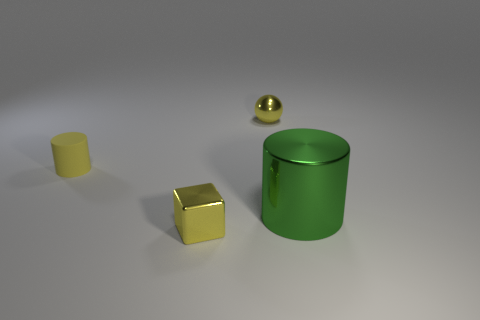What number of small yellow balls are there?
Your answer should be very brief. 1. What number of objects are green things or yellow matte blocks?
Ensure brevity in your answer.  1. There is a ball that is the same color as the rubber thing; what is its size?
Offer a very short reply. Small. There is a small metallic cube; are there any yellow matte things in front of it?
Your answer should be compact. No. Is the number of yellow objects that are behind the tiny yellow shiny cube greater than the number of big cylinders that are behind the yellow ball?
Offer a very short reply. Yes. There is another yellow thing that is the same shape as the large metal thing; what is its size?
Offer a terse response. Small. How many cylinders are green metal things or metal things?
Ensure brevity in your answer.  1. There is a small sphere that is the same color as the tiny cylinder; what is its material?
Your response must be concise. Metal. Is the number of yellow balls to the left of the yellow metal sphere less than the number of things in front of the metallic cylinder?
Your response must be concise. Yes. How many things are either metal things behind the small cube or green matte objects?
Your answer should be very brief. 2. 